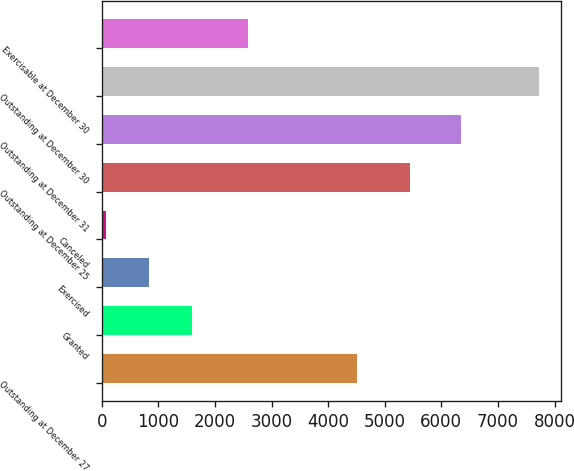Convert chart to OTSL. <chart><loc_0><loc_0><loc_500><loc_500><bar_chart><fcel>Outstanding at December 27<fcel>Granted<fcel>Exercised<fcel>Canceled<fcel>Outstanding at December 25<fcel>Outstanding at December 31<fcel>Outstanding at December 30<fcel>Exercisable at December 30<nl><fcel>4514<fcel>1598<fcel>832<fcel>66<fcel>5450<fcel>6354<fcel>7726<fcel>2591<nl></chart> 